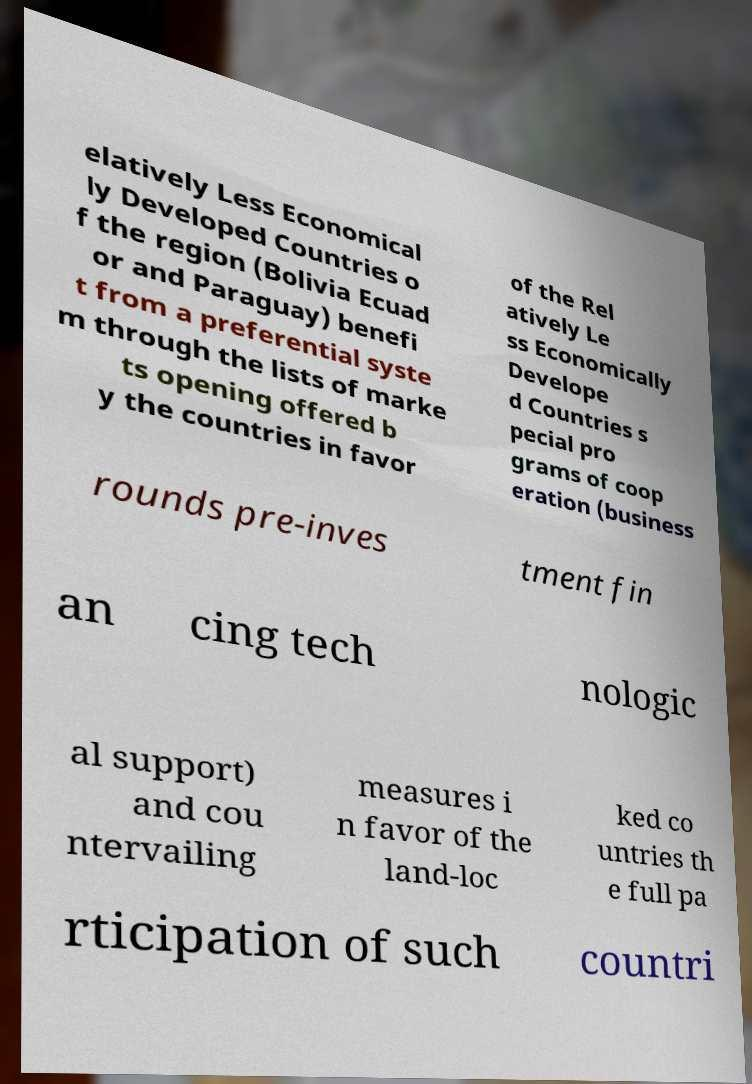There's text embedded in this image that I need extracted. Can you transcribe it verbatim? elatively Less Economical ly Developed Countries o f the region (Bolivia Ecuad or and Paraguay) benefi t from a preferential syste m through the lists of marke ts opening offered b y the countries in favor of the Rel atively Le ss Economically Develope d Countries s pecial pro grams of coop eration (business rounds pre-inves tment fin an cing tech nologic al support) and cou ntervailing measures i n favor of the land-loc ked co untries th e full pa rticipation of such countri 